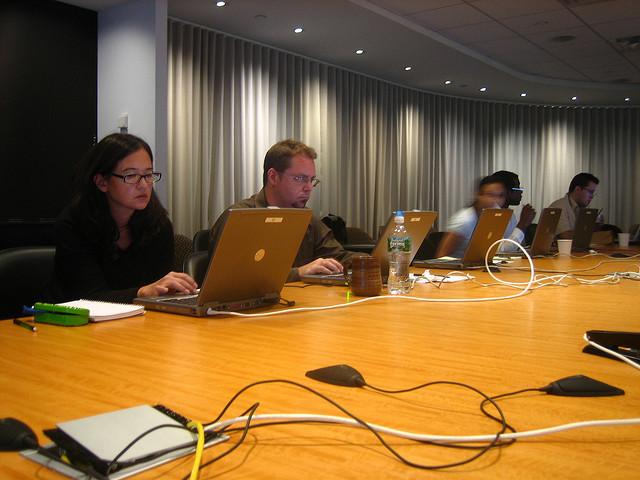What brand are those laptops?
Quick response, please. Dell. How many people have computers?
Concise answer only. 5. Are the people conversing?
Answer briefly. No. 